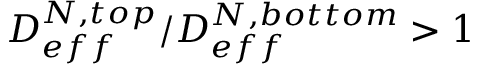Convert formula to latex. <formula><loc_0><loc_0><loc_500><loc_500>{ { D _ { e f f } ^ { N , t o p } } / { D _ { e f f } ^ { N , b o t t o m } } > 1 }</formula> 